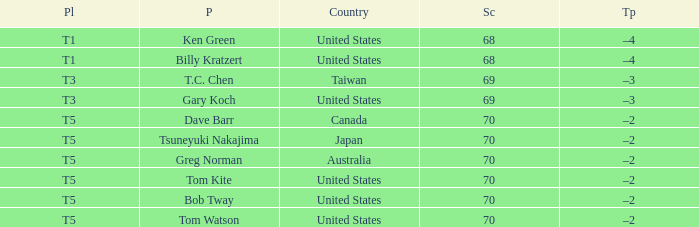What is the lowest score that Bob Tway get when he placed t5? 70.0. Parse the full table. {'header': ['Pl', 'P', 'Country', 'Sc', 'Tp'], 'rows': [['T1', 'Ken Green', 'United States', '68', '–4'], ['T1', 'Billy Kratzert', 'United States', '68', '–4'], ['T3', 'T.C. Chen', 'Taiwan', '69', '–3'], ['T3', 'Gary Koch', 'United States', '69', '–3'], ['T5', 'Dave Barr', 'Canada', '70', '–2'], ['T5', 'Tsuneyuki Nakajima', 'Japan', '70', '–2'], ['T5', 'Greg Norman', 'Australia', '70', '–2'], ['T5', 'Tom Kite', 'United States', '70', '–2'], ['T5', 'Bob Tway', 'United States', '70', '–2'], ['T5', 'Tom Watson', 'United States', '70', '–2']]} 